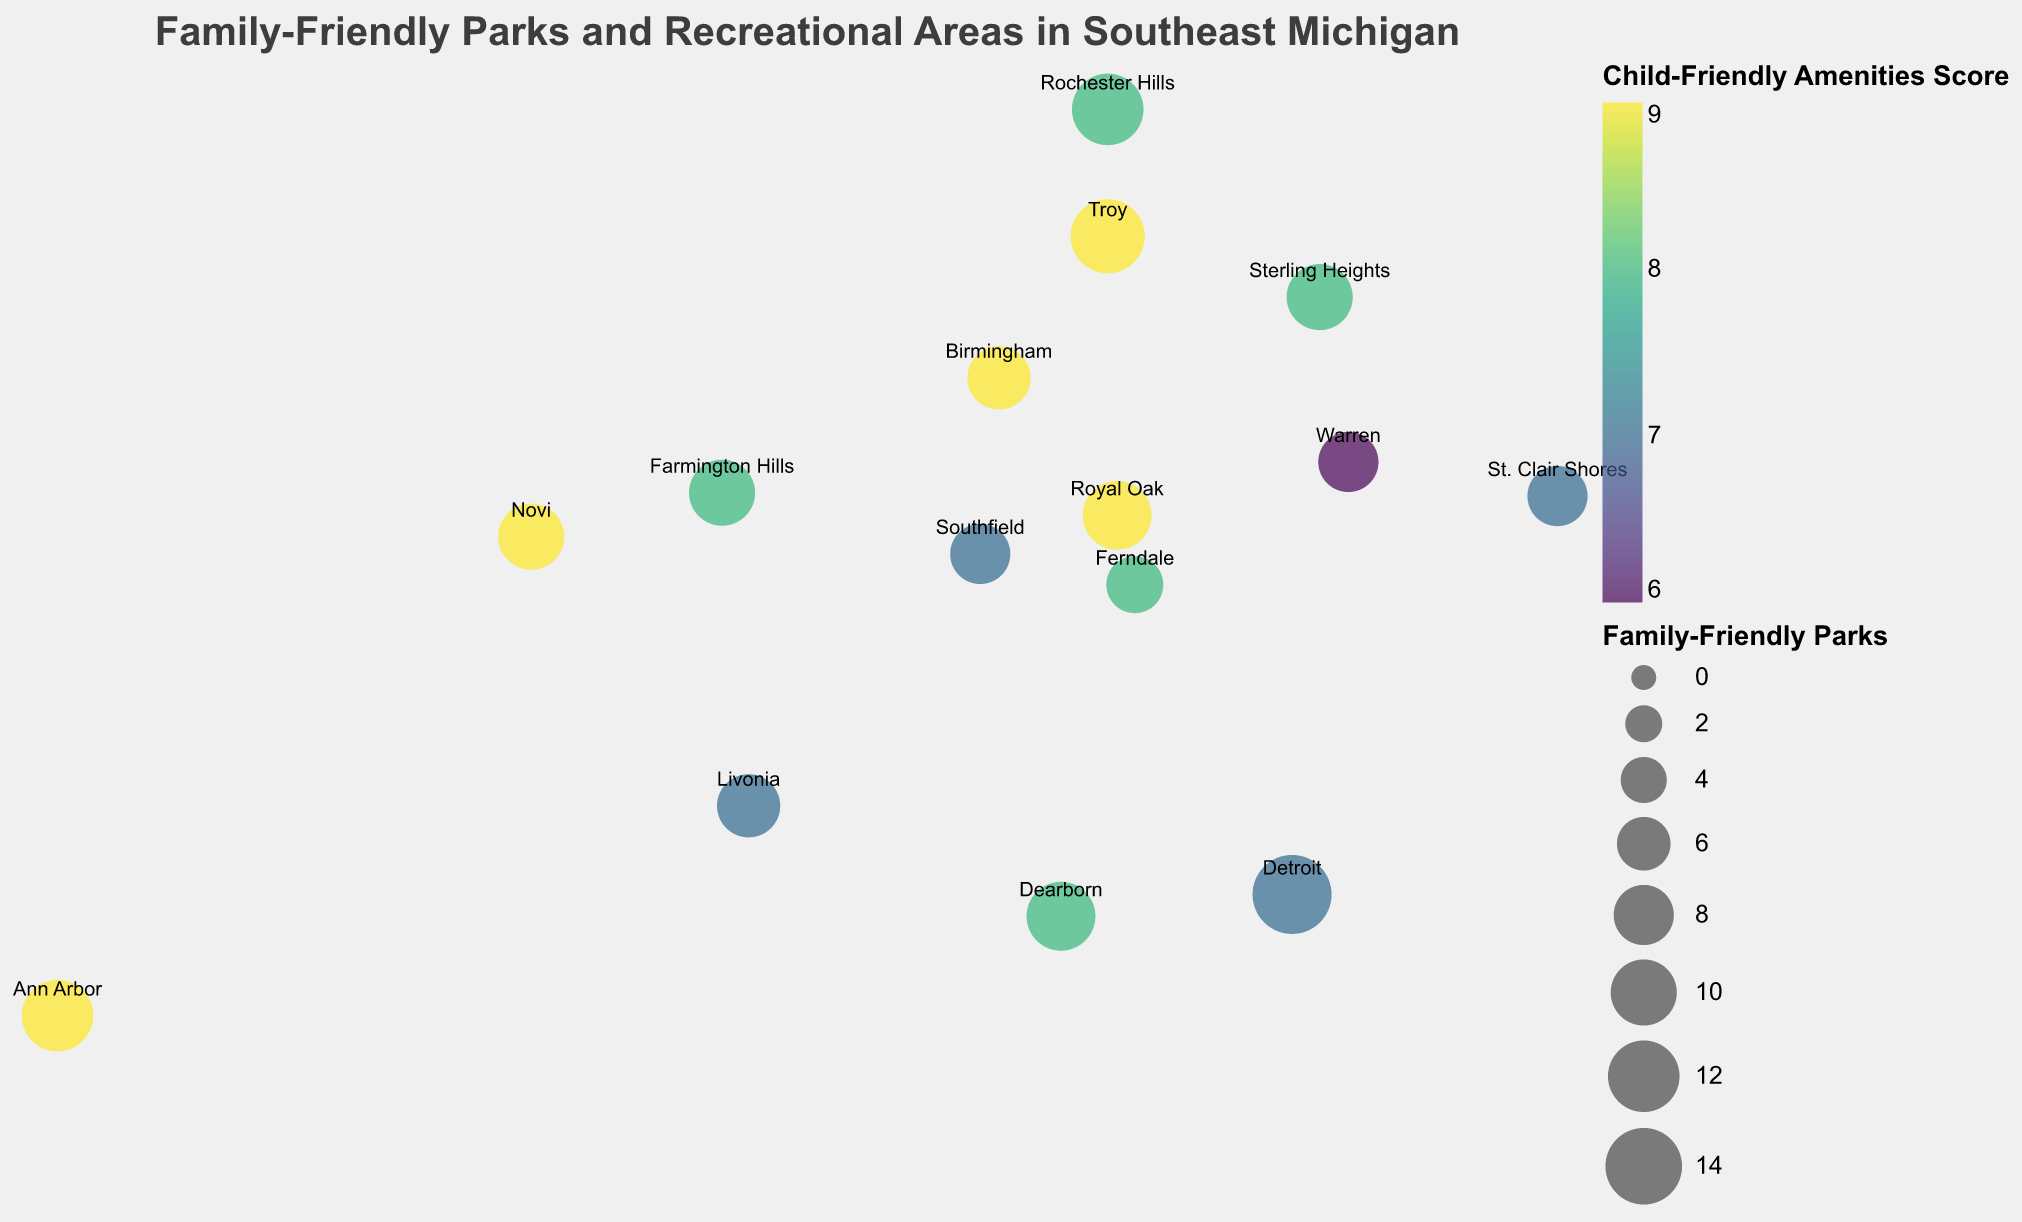What does the title of the plot say? The title is usually at the top center of the plot and describes what the data visualization is about.
Answer: Family-Friendly Parks and Recreational Areas in Southeast Michigan Which city has the most family-friendly parks? Look at the size of the circles, which represent the number of family-friendly parks. The largest circle will indicate the city with the most parks.
Answer: Detroit Which two cities have a family-friendly parks count of 12? Identify the circles with a size that corresponds to 12 parks and then read the city names near those circles.
Answer: Ann Arbor and Rochester Hills How many cities have a Child-Friendly Amenities Score of 9? Observe the color of the circles which represents the Child-Friendly Amenities Score using the color legend and count how many are labeled with the score 9.
Answer: 5 Which city has the lowest Recreational Areas count and what is the count? Identify the smallest value in the Recreational Areas column by looking at the visual sizes or by finding the smallest circle corresponding to recreational areas.
Answer: Ferndale, 4 What’s the average number of family-friendly parks in all the cities shown? Add up the number of family-friendly parks for all cities and divide by the number of cities. (15 + 12 + 8 + 10 + 9 + 11 + 13 + 10 + 8 + 11 + 7 + 9 + 12 + 10 + 8)/15 = 143/15
Answer: 9.53 Compare the number of recreational areas in Troy and Livonia. Which city has more and by how much? Find the circle sizes associated with Troy and Livonia for recreational areas and subtract the smaller count from the larger one.
Answer: Troy has 2 more recreational areas than Livonia (8 - 6) Which city scored highest in Child-Friendly Amenities Score and how does it compare to Detroit's score? Look for the circle that is the darkest color (according to the color legend which represents the highest score) and then compare it with Detroit's score. Multiple cities share the highest score of 9 (Ann Arbor, Troy, Royal Oak, Birmingham, Novi), which is 2 points higher than Detroit's score of 7.
Answer: Ann Arbor, Troy, Royal Oak, Birmingham, Novi scored highest and are 2 points higher than Detroit Identify a city with both a high number of family-friendly parks and a high Child-Friendly Amenities Score. Look for a city that has a large circle size (indicating many parks) and a dark color (indicating a high score). For example, Troy is an ideal candidate with 13 family-friendly parks and a score of 9.
Answer: Troy Are there any cities with an equal number of Recreational Areas and Family-Friendly Parks? Compare the counts in the Recreational Areas and Family-Friendly Parks columns for each city to see if any are equal. There are no cities where the Recreational Areas and Family-Friendly Parks counts are identical in this dataset.
Answer: No 